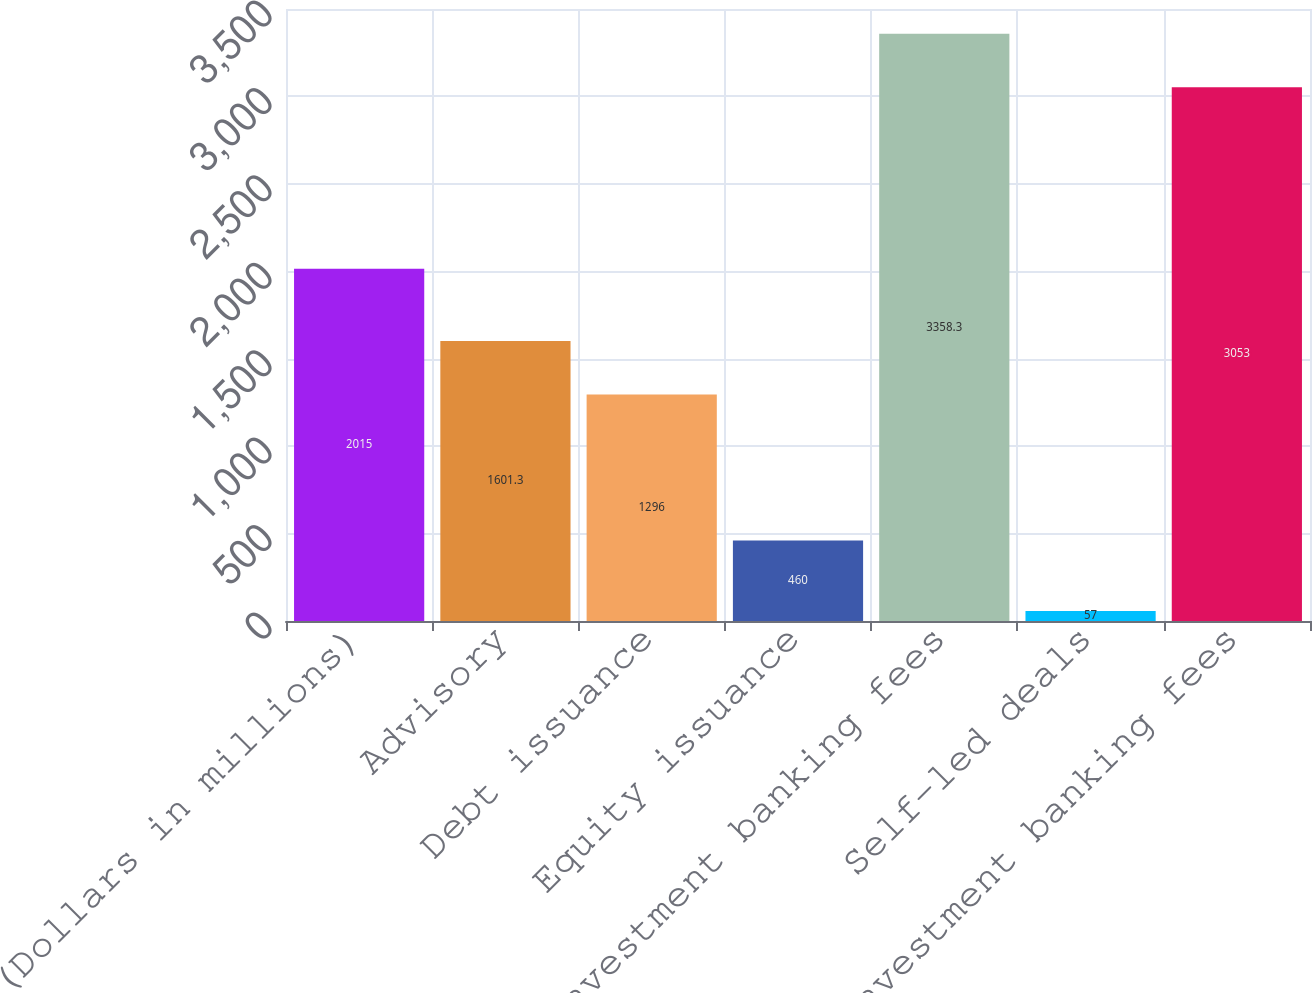<chart> <loc_0><loc_0><loc_500><loc_500><bar_chart><fcel>(Dollars in millions)<fcel>Advisory<fcel>Debt issuance<fcel>Equity issuance<fcel>Gross investment banking fees<fcel>Self-led deals<fcel>Total investment banking fees<nl><fcel>2015<fcel>1601.3<fcel>1296<fcel>460<fcel>3358.3<fcel>57<fcel>3053<nl></chart> 